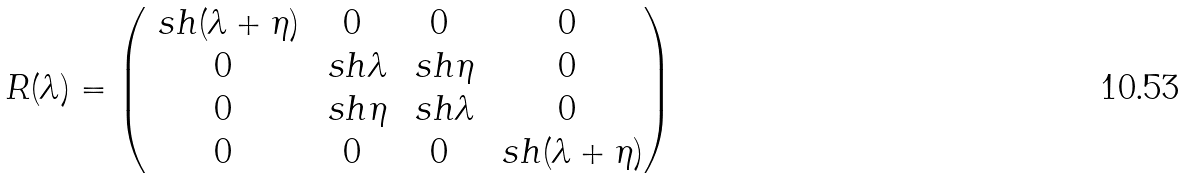Convert formula to latex. <formula><loc_0><loc_0><loc_500><loc_500>R ( \lambda ) = \begin{pmatrix} \ s h ( \lambda + \eta ) & 0 & 0 & 0 \\ 0 & \ s h \lambda & \ s h \eta & 0 \\ 0 & \ s h \eta & \ s h \lambda & 0 \\ 0 & 0 & 0 & \ s h ( \lambda + \eta ) \end{pmatrix}</formula> 